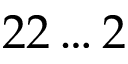Convert formula to latex. <formula><loc_0><loc_0><loc_500><loc_500>2 2 \dots 2</formula> 